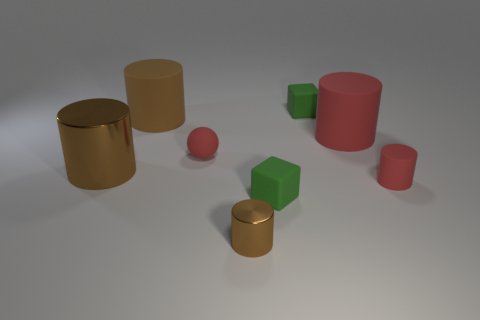Subtract all brown cylinders. How many were subtracted if there are1brown cylinders left? 2 Subtract all matte cylinders. How many cylinders are left? 2 Subtract 1 cylinders. How many cylinders are left? 4 Subtract all red cylinders. How many cylinders are left? 3 Subtract all cylinders. How many objects are left? 3 Subtract all gray cubes. Subtract all red spheres. How many cubes are left? 2 Subtract all yellow spheres. How many brown cylinders are left? 3 Subtract all purple cylinders. Subtract all matte cylinders. How many objects are left? 5 Add 2 big cylinders. How many big cylinders are left? 5 Add 7 large brown things. How many large brown things exist? 9 